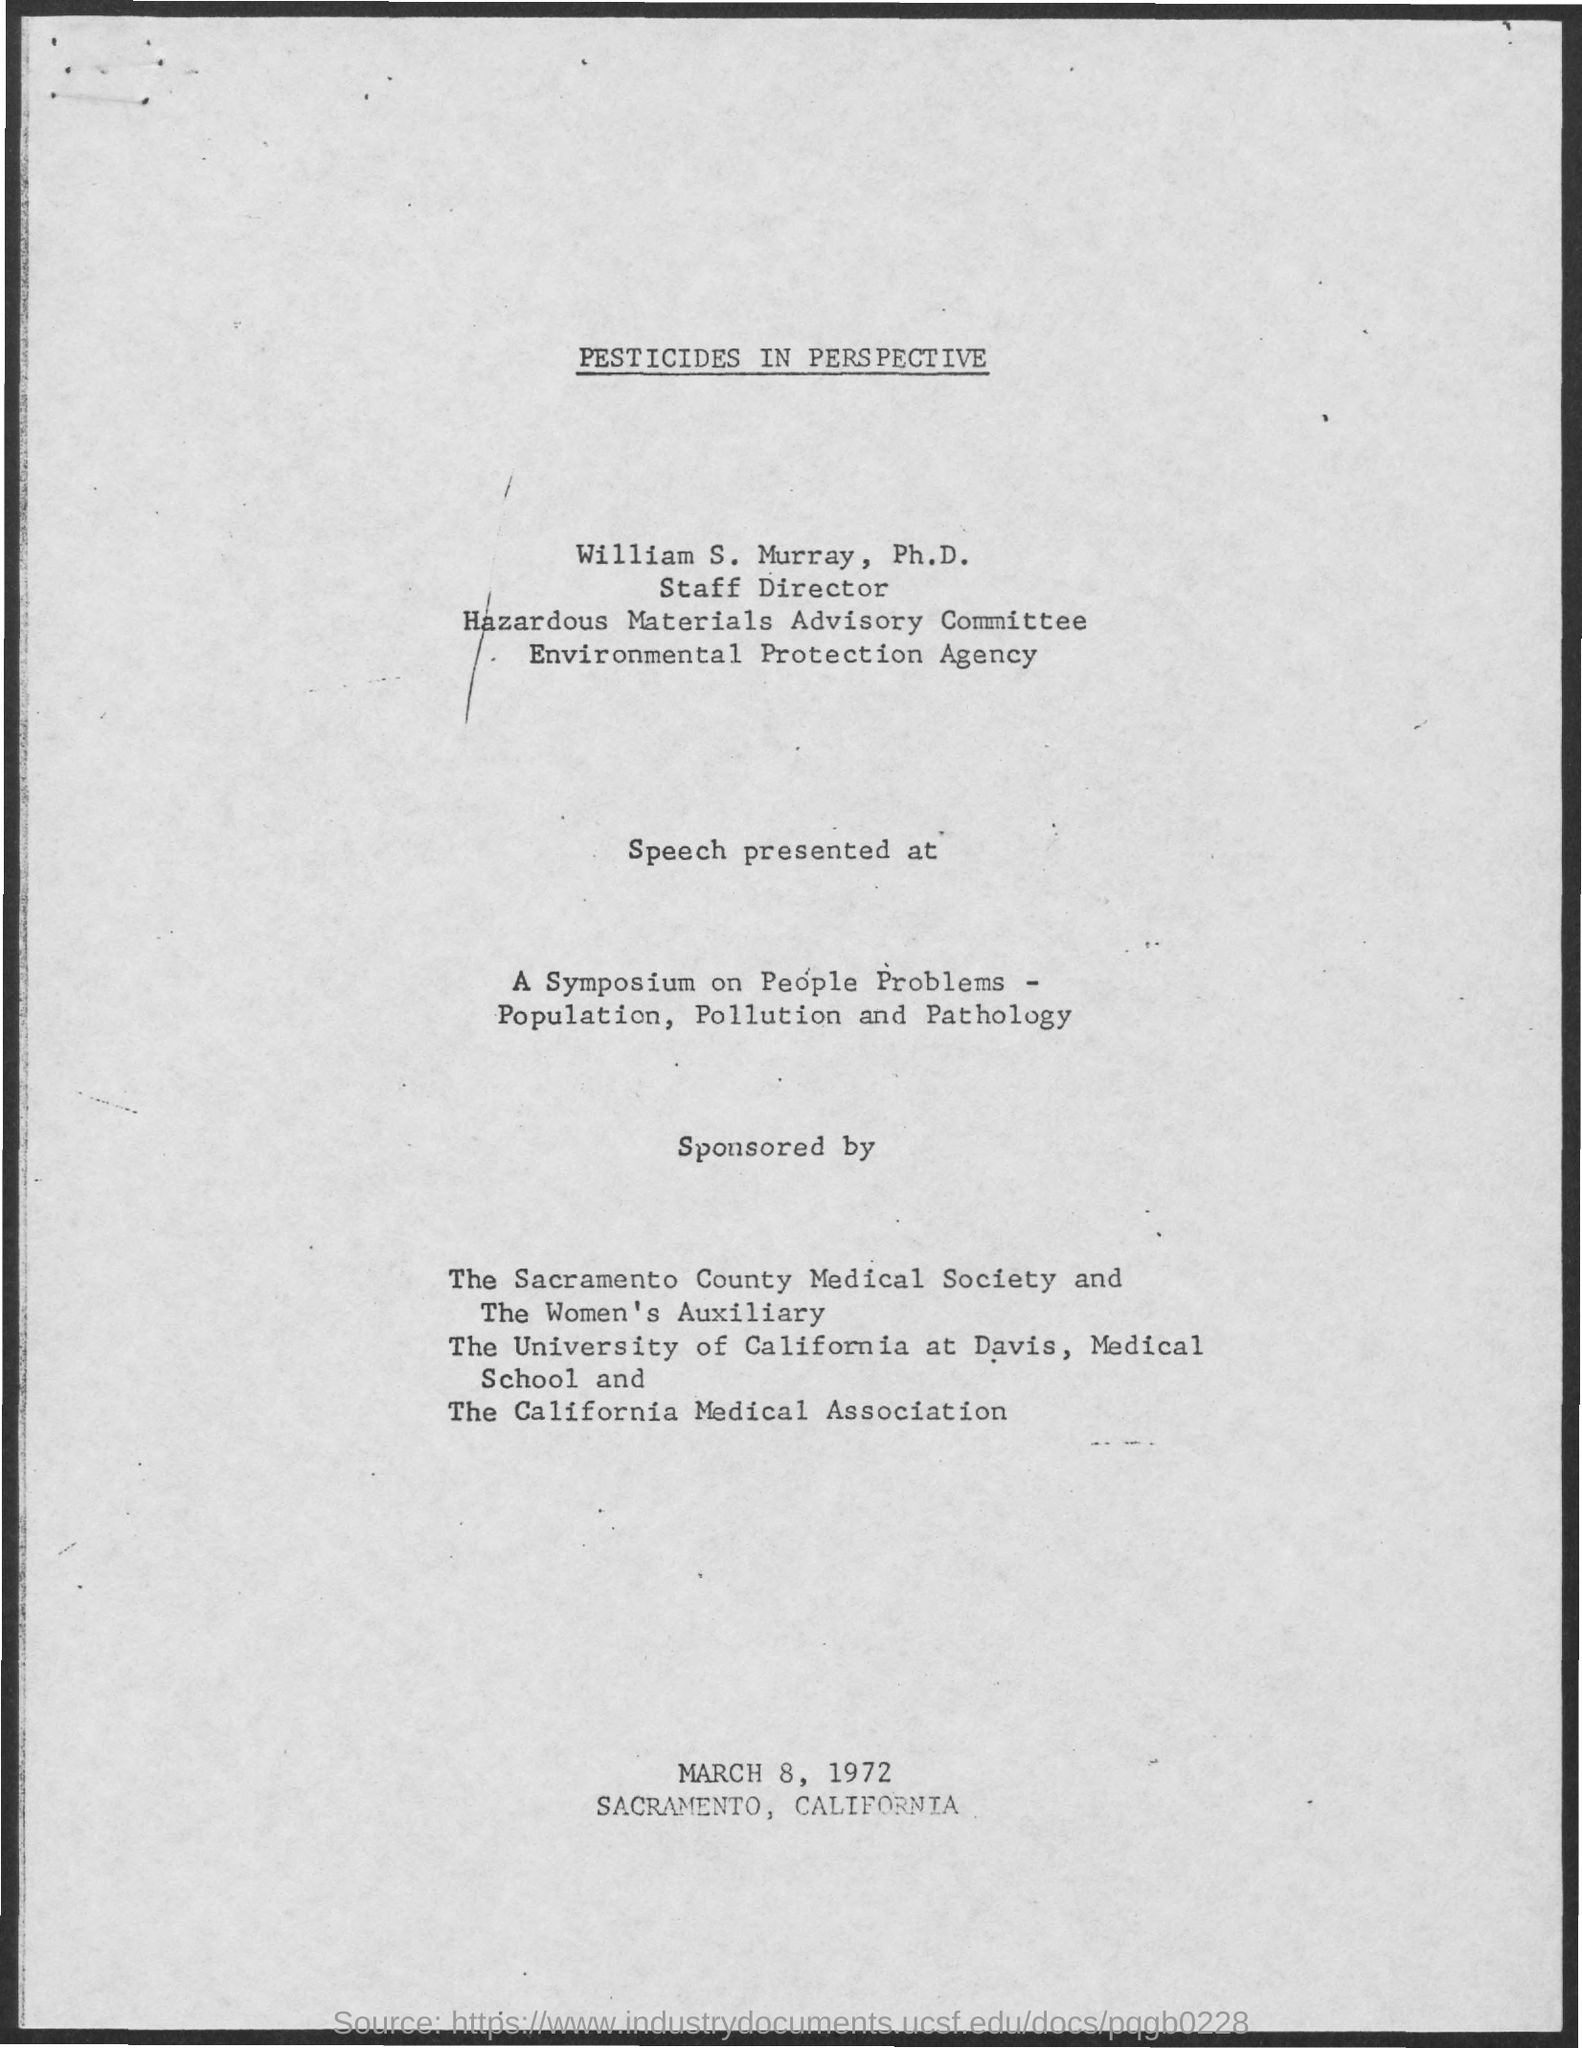Who is the staff director of Hazardous Materials Advisory Committee?
Provide a short and direct response. WILLIAM S. MURRAY. 